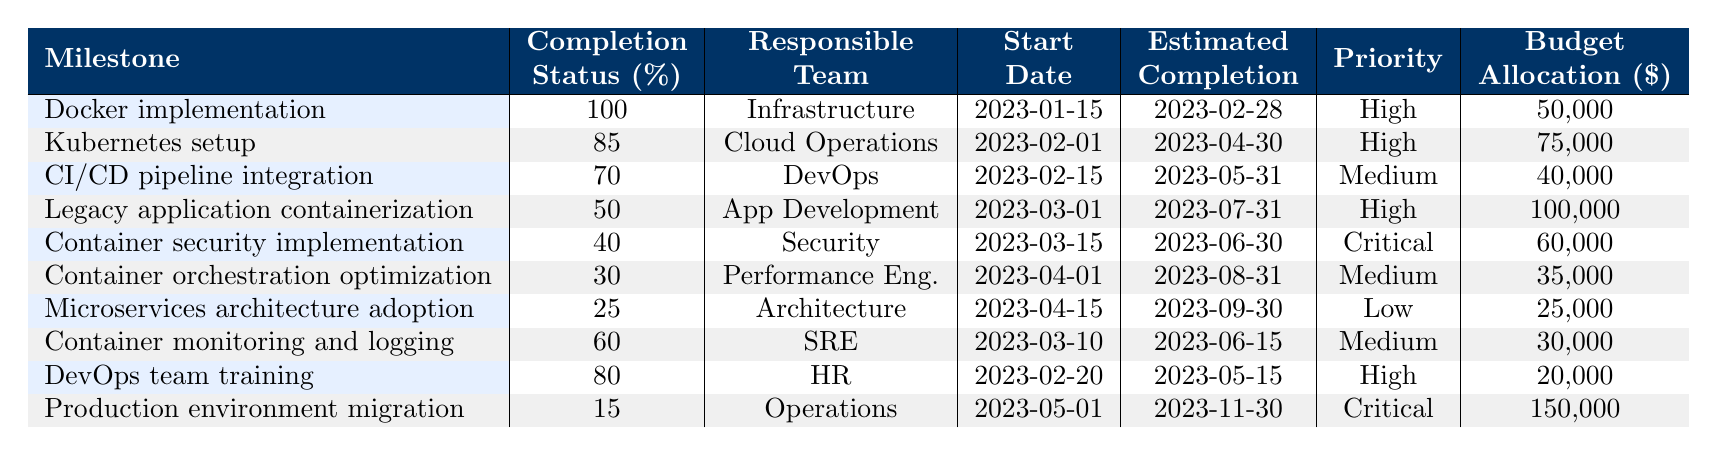What is the completion status of the "CI/CD pipeline integration" milestone? The milestone "CI/CD pipeline integration" has a completion status of 70%. This value is directly read from the table under the "Completion Status (%)" column.
Answer: 70% Which milestone has the highest budget allocation? The milestone with the highest budget allocation is "Production environment migration" with a budget of $150,000. This is determined by comparing the budget values listed in the table.
Answer: $150,000 Is "Container orchestration optimization" responsible by the DevOps team? No, "Container orchestration optimization" is assigned to the Performance Engineering team, not the DevOps team. This information can be found in the "Responsible Team" column of the table.
Answer: No What is the average completion status of all milestones? To find the average completion status, sum up the completion percentages (100 + 85 + 70 + 50 + 40 + 30 + 25 + 60 + 80 + 15 =  555) and divide by the number of milestones (10). The average is 555 / 10 = 55.5%.
Answer: 55.5% Which milestone has the lowest completion status and what is that status? The milestone with the lowest completion status is "Microservices architecture adoption" with a status of 25%. This can be identified by looking at the completion percentages and selecting the minimum value.
Answer: 25% What is the total budget allocated for high-priority milestones? The high-priority milestones are "Docker implementation," "Kubernetes setup," "Legacy application containerization," "DevOps team training," and "Production environment migration." Their budgets are (50,000 + 75,000 + 100,000 + 20,000 + 150,000) = 395,000. Thus, the total budget for high-priority milestones is $395,000.
Answer: $395,000 Which team is responsible for the "Container security implementation," and what is the completion status? The "Container security implementation" is handled by the Security team and has a completion status of 40%. This is found by referencing the appropriate columns for this milestone.
Answer: Security team, 40% How many milestones have a completion status of 60% or higher? The milestones with a completion status of 60% or higher include "Docker implementation," "Kubernetes setup," "CI/CD pipeline integration," "Container monitoring and logging," and "DevOps team training." That makes a total of five milestones.
Answer: 5 What is the difference in budget between the highest and lowest budget allocations? The highest budget allocation is $150,000 for "Production environment migration," and the lowest is $25,000 for "Microservices architecture adoption." The difference is calculated as 150,000 - 25,000 = 125,000.
Answer: $125,000 What are the responsibilities of the team that is in charge of "Kubernetes setup"? The "Kubernetes setup" milestone is the responsibility of the Cloud Operations team. This can be verified by looking at the "Responsible Team" column for this specific milestone.
Answer: Cloud Operations team 